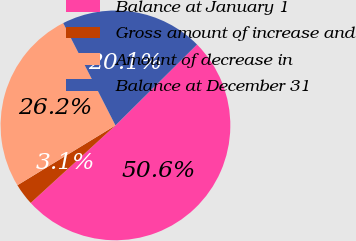Convert chart to OTSL. <chart><loc_0><loc_0><loc_500><loc_500><pie_chart><fcel>Balance at January 1<fcel>Gross amount of increase and<fcel>Amount of decrease in<fcel>Balance at December 31<nl><fcel>50.64%<fcel>3.07%<fcel>26.21%<fcel>20.08%<nl></chart> 